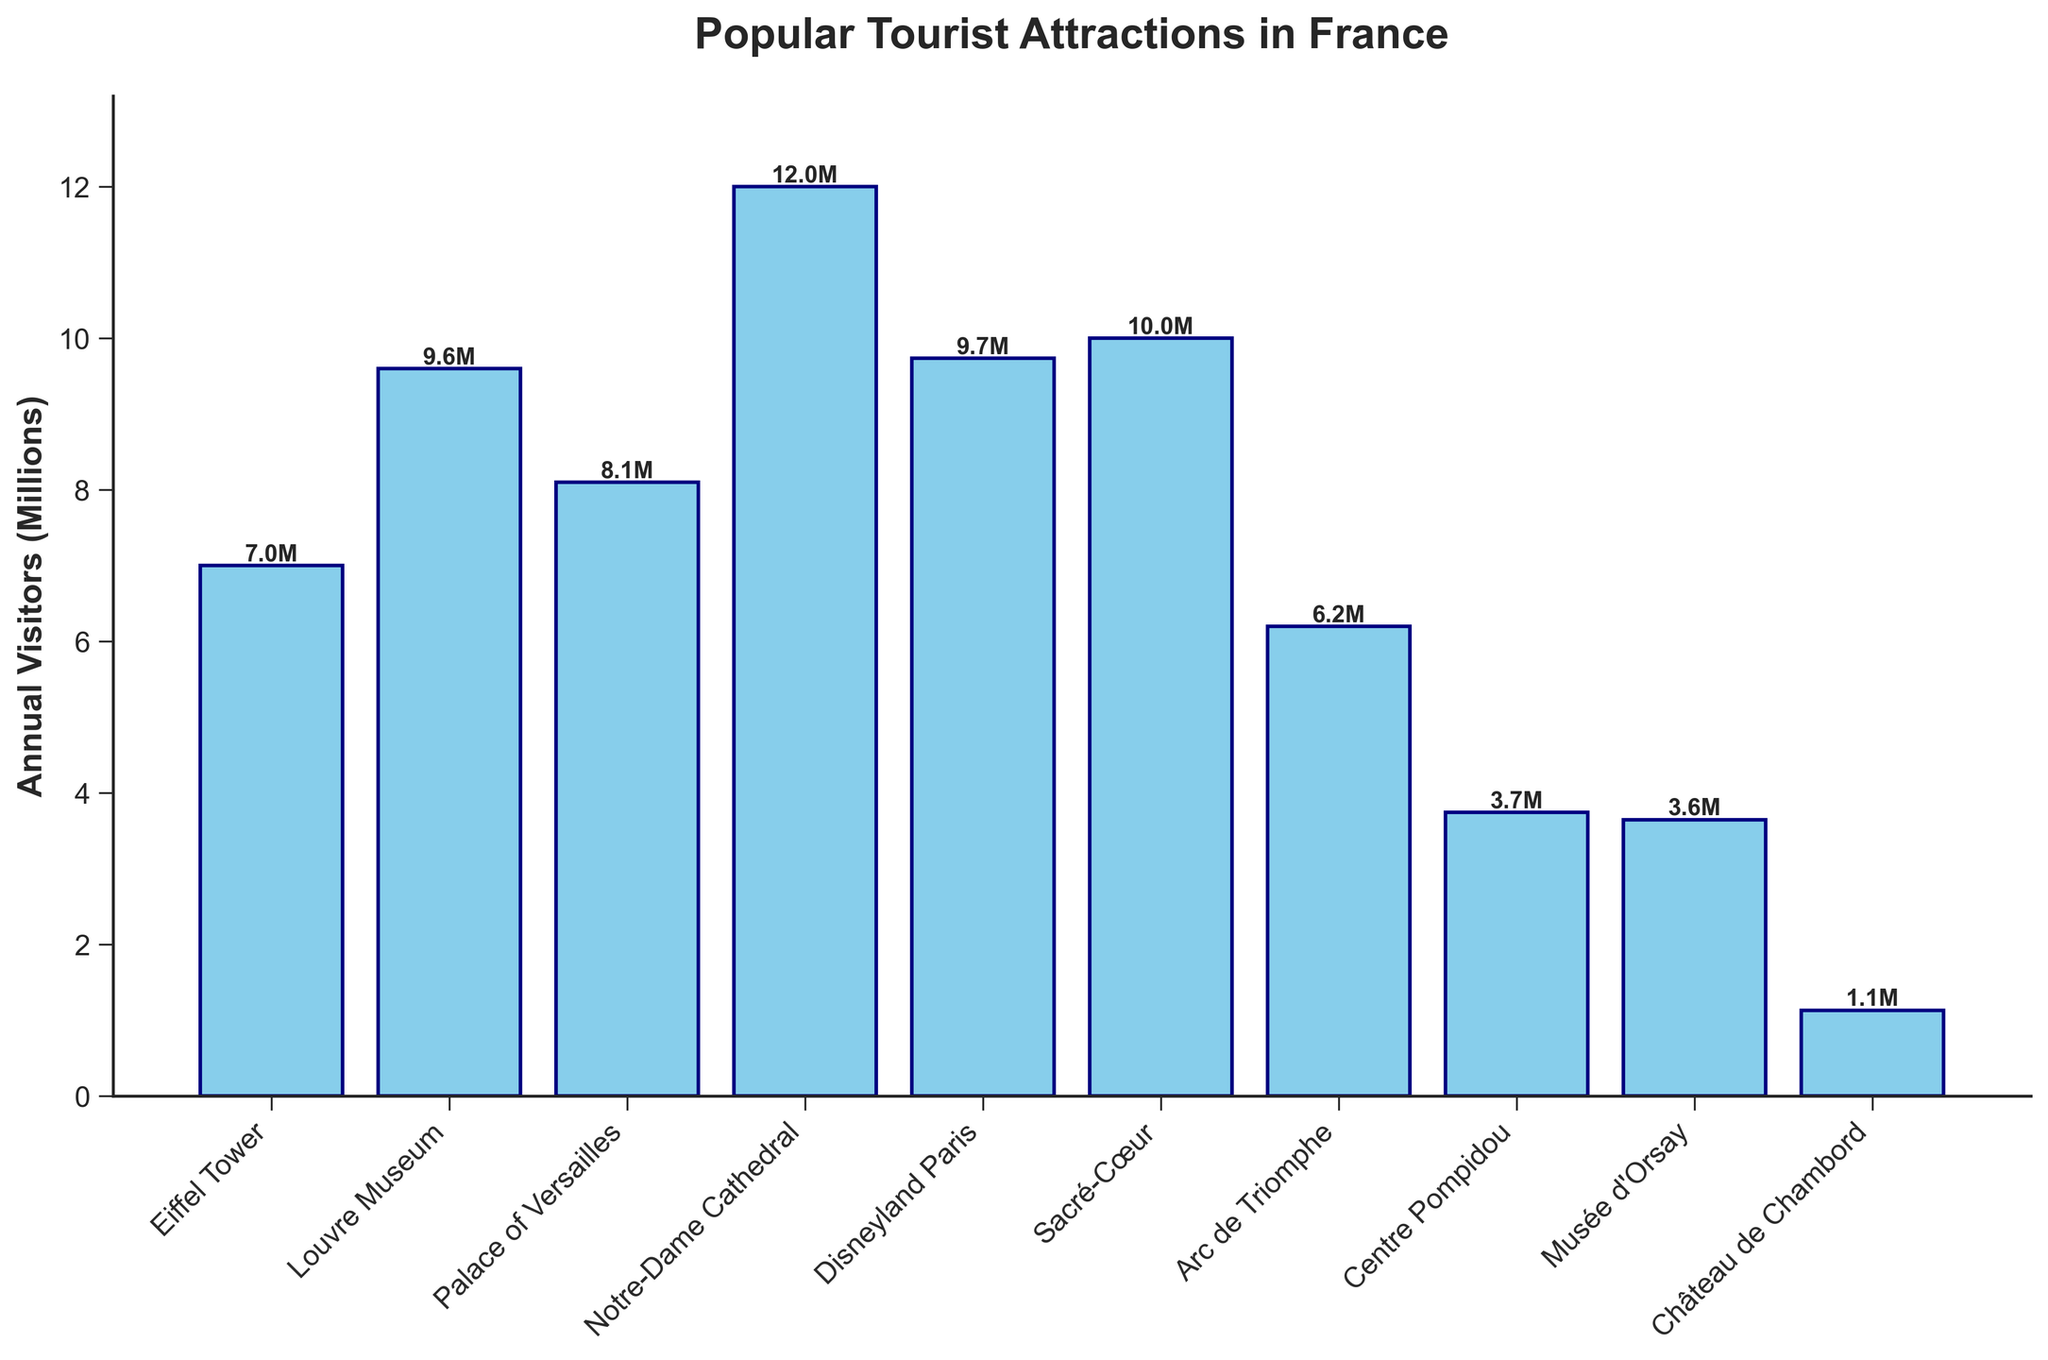What is the attraction with the highest number of annual visitors? The figure shows that the Notre-Dame Cathedral has the tallest bar, representing the highest number of annual visitors.
Answer: Notre-Dame Cathedral Which attraction has more visitors, the Louvre Museum or Disneyland Paris? Comparing the heights of the bars for the Louvre Museum and Disneyland Paris, the Louvre Museum bar is taller.
Answer: Louvre Museum What is the total number of visitors for the Eiffel Tower and the Arc de Triomphe combined? The Eiffel Tower has 7 million visitors and the Arc de Triomphe has 6.2 million visitors. Adding them together: 7 + 6.2 = 13.2 million.
Answer: 13.2 million Which attractions have more than 9 million visitors annually? By looking at the bars and their labels, the Louvre Museum, Notre-Dame Cathedral, Disneyland Paris, and Sacré-Cœur all exceed 9 million visitors annually.
Answer: Louvre Museum, Notre-Dame Cathedral, Disneyland Paris, Sacré-Cœur What is the difference in annual visitors between the Sacré-Cœur and the Château de Chambord? The Sacré-Cœur has 10 million visitors and the Château de Chambord has 1.13 million visitors. The difference is: 10 - 1.13 = 8.87 million.
Answer: 8.87 million Which attraction has the lowest number of visitors? The figure shows that the Château de Chambord has the shortest bar, indicating it has the lowest number of visitors.
Answer: Château de Chambord How many attractions have between 3 million and 7 million visitors annually? The bars representing the Arc de Triomphe, Centre Pompidou, and Musée d'Orsay fall within the 3 to 7 million range.
Answer: 3 What is the average number of visitors to the attractions listed? Summing the visitors: 7 + 9.6 + 8.1 + 12 + 9.74 + 10 + 6.2 + 3.745 + 3.65 + 1.13 = 71.165 million. Dividing by the number of attractions (10): 71.165 / 10 = 7.1165 million.
Answer: 7.12 million Which has more visitors: Eiffel Tower and Louvre Museum combined or Notre-Dame Cathedral alone? Eiffel Tower has 7 million and Louvre Museum has 9.6 million visitors. Combined is: 7 + 9.6 = 16.6 million. Notre-Dame Cathedral alone has 12 million. Comparing: 16.6 million > 12 million.
Answer: Eiffel Tower and Louvre Museum combined 